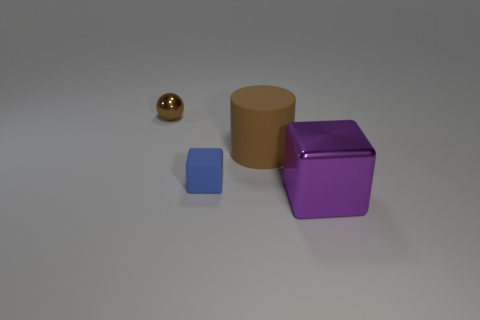Add 1 cyan balls. How many objects exist? 5 Subtract all spheres. How many objects are left? 3 Add 4 balls. How many balls exist? 5 Subtract 0 red blocks. How many objects are left? 4 Subtract all large metal blocks. Subtract all tiny blue rubber things. How many objects are left? 2 Add 3 big matte things. How many big matte things are left? 4 